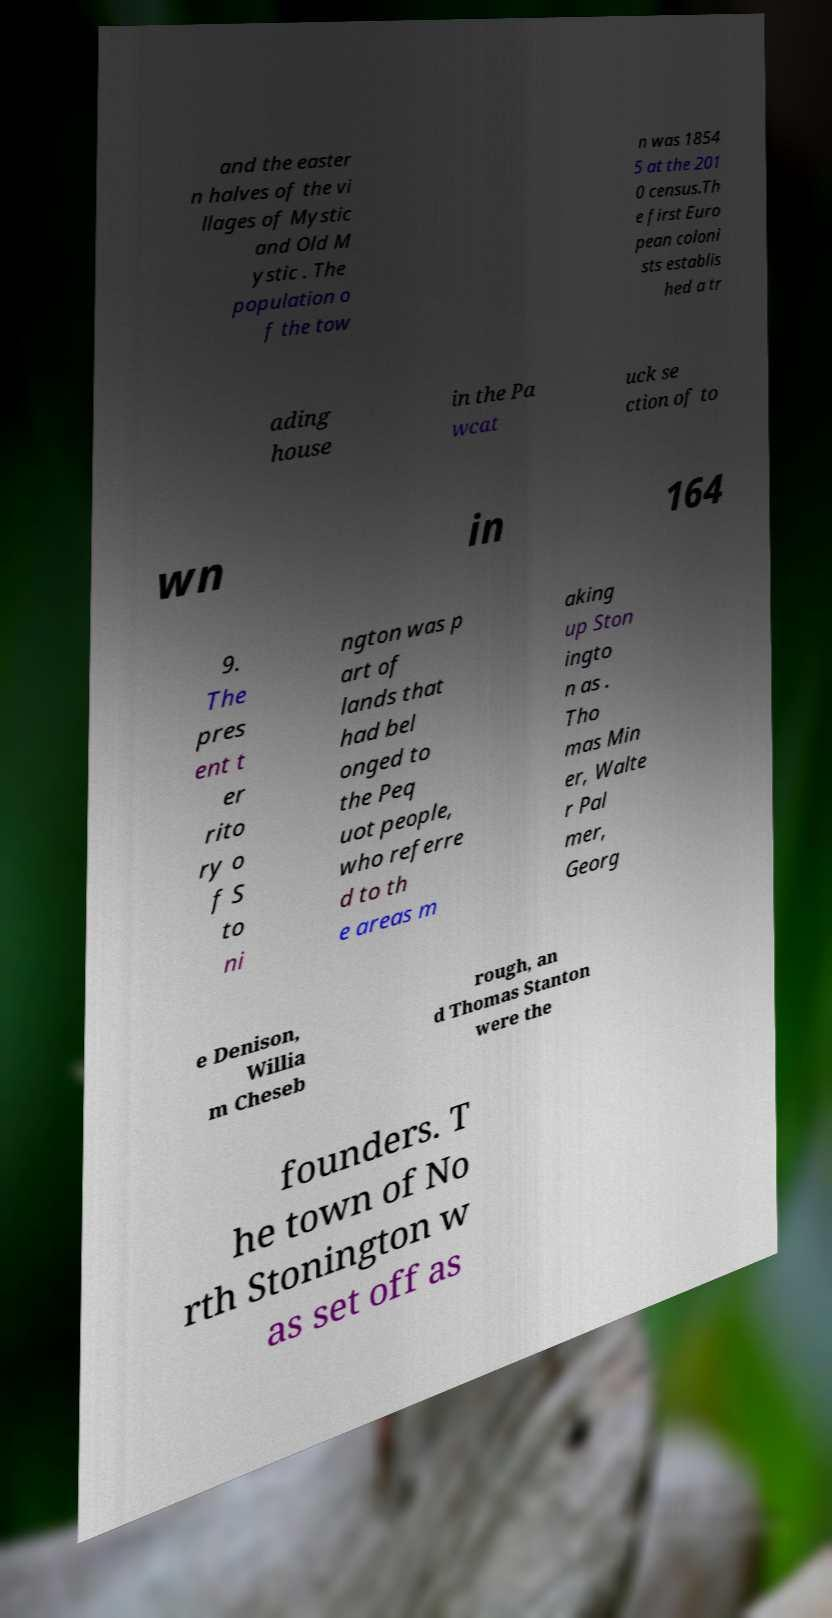What messages or text are displayed in this image? I need them in a readable, typed format. and the easter n halves of the vi llages of Mystic and Old M ystic . The population o f the tow n was 1854 5 at the 201 0 census.Th e first Euro pean coloni sts establis hed a tr ading house in the Pa wcat uck se ction of to wn in 164 9. The pres ent t er rito ry o f S to ni ngton was p art of lands that had bel onged to the Peq uot people, who referre d to th e areas m aking up Ston ingto n as . Tho mas Min er, Walte r Pal mer, Georg e Denison, Willia m Cheseb rough, an d Thomas Stanton were the founders. T he town of No rth Stonington w as set off as 